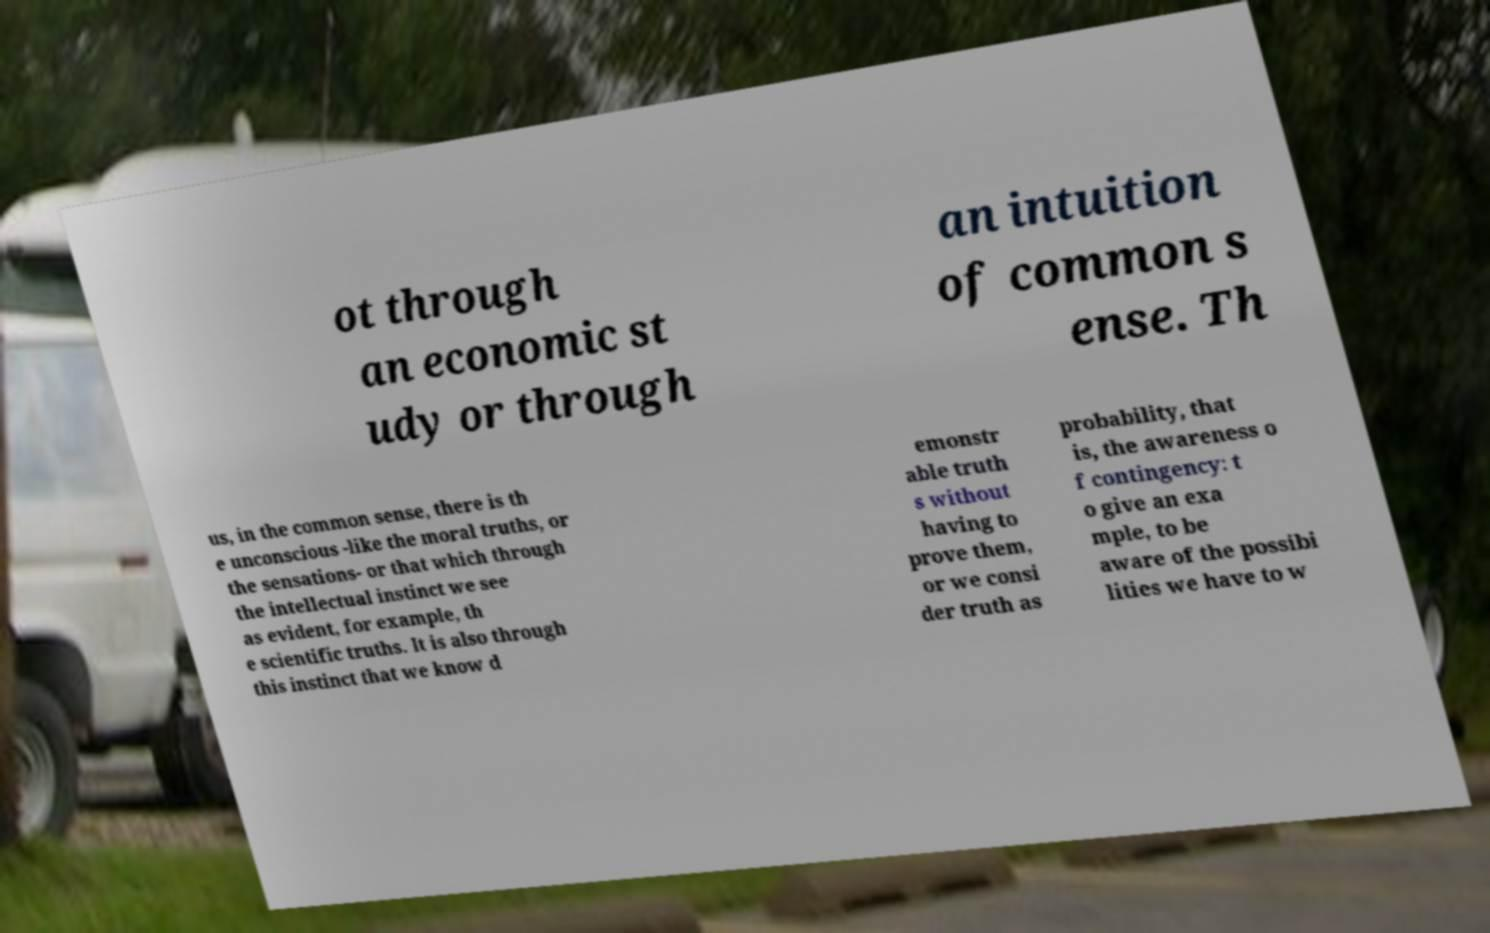Please identify and transcribe the text found in this image. ot through an economic st udy or through an intuition of common s ense. Th us, in the common sense, there is th e unconscious -like the moral truths, or the sensations- or that which through the intellectual instinct we see as evident, for example, th e scientific truths. It is also through this instinct that we know d emonstr able truth s without having to prove them, or we consi der truth as probability, that is, the awareness o f contingency: t o give an exa mple, to be aware of the possibi lities we have to w 